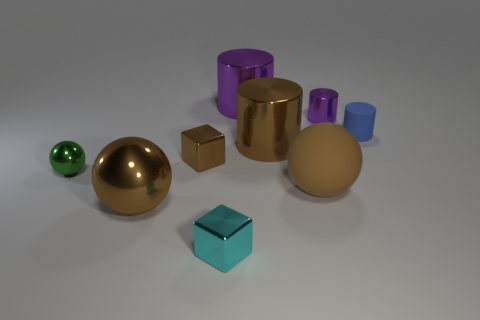There is a blue matte object; does it have the same shape as the big object left of the large purple metal object?
Give a very brief answer. No. Is there any other thing that has the same material as the tiny purple cylinder?
Make the answer very short. Yes. What is the material of the brown object that is the same shape as the blue object?
Your response must be concise. Metal. How many large objects are cubes or green metal cubes?
Ensure brevity in your answer.  0. Is the number of matte objects to the left of the green object less than the number of purple objects that are left of the small blue cylinder?
Your response must be concise. Yes. How many things are red matte spheres or large purple shiny objects?
Provide a succinct answer. 1. There is a large purple thing; what number of large brown matte spheres are behind it?
Ensure brevity in your answer.  0. Is the tiny metallic cylinder the same color as the small matte thing?
Your response must be concise. No. The small purple thing that is made of the same material as the small ball is what shape?
Your response must be concise. Cylinder. There is a large brown shiny thing right of the cyan object; is its shape the same as the small blue matte thing?
Ensure brevity in your answer.  Yes. 